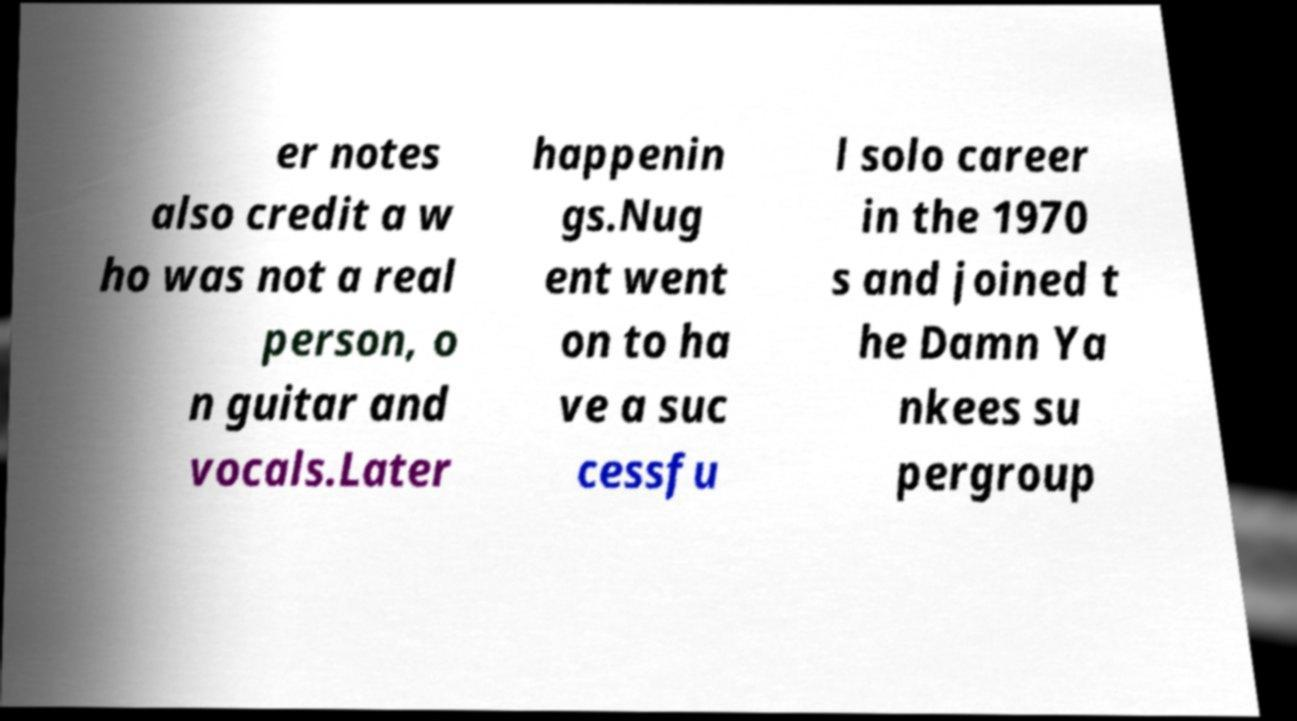Could you extract and type out the text from this image? er notes also credit a w ho was not a real person, o n guitar and vocals.Later happenin gs.Nug ent went on to ha ve a suc cessfu l solo career in the 1970 s and joined t he Damn Ya nkees su pergroup 